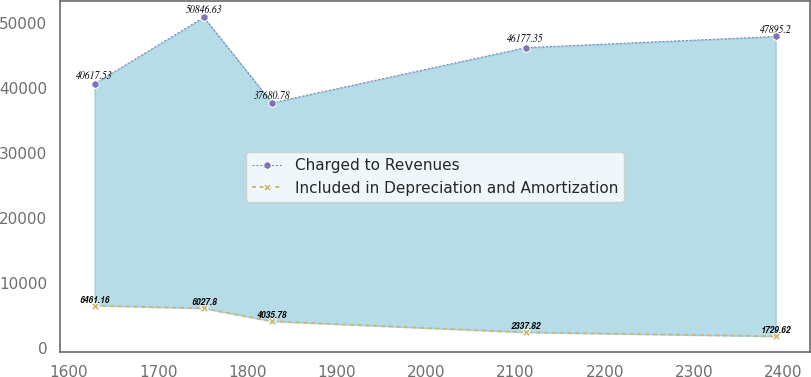Convert chart. <chart><loc_0><loc_0><loc_500><loc_500><line_chart><ecel><fcel>Charged to Revenues<fcel>Included in Depreciation and Amortization<nl><fcel>1628.62<fcel>40617.5<fcel>6461.16<nl><fcel>1750.97<fcel>50846.6<fcel>6027.8<nl><fcel>1827.23<fcel>37680.8<fcel>4035.78<nl><fcel>2111.19<fcel>46177.3<fcel>2337.82<nl><fcel>2391.25<fcel>47895.2<fcel>1729.62<nl></chart> 